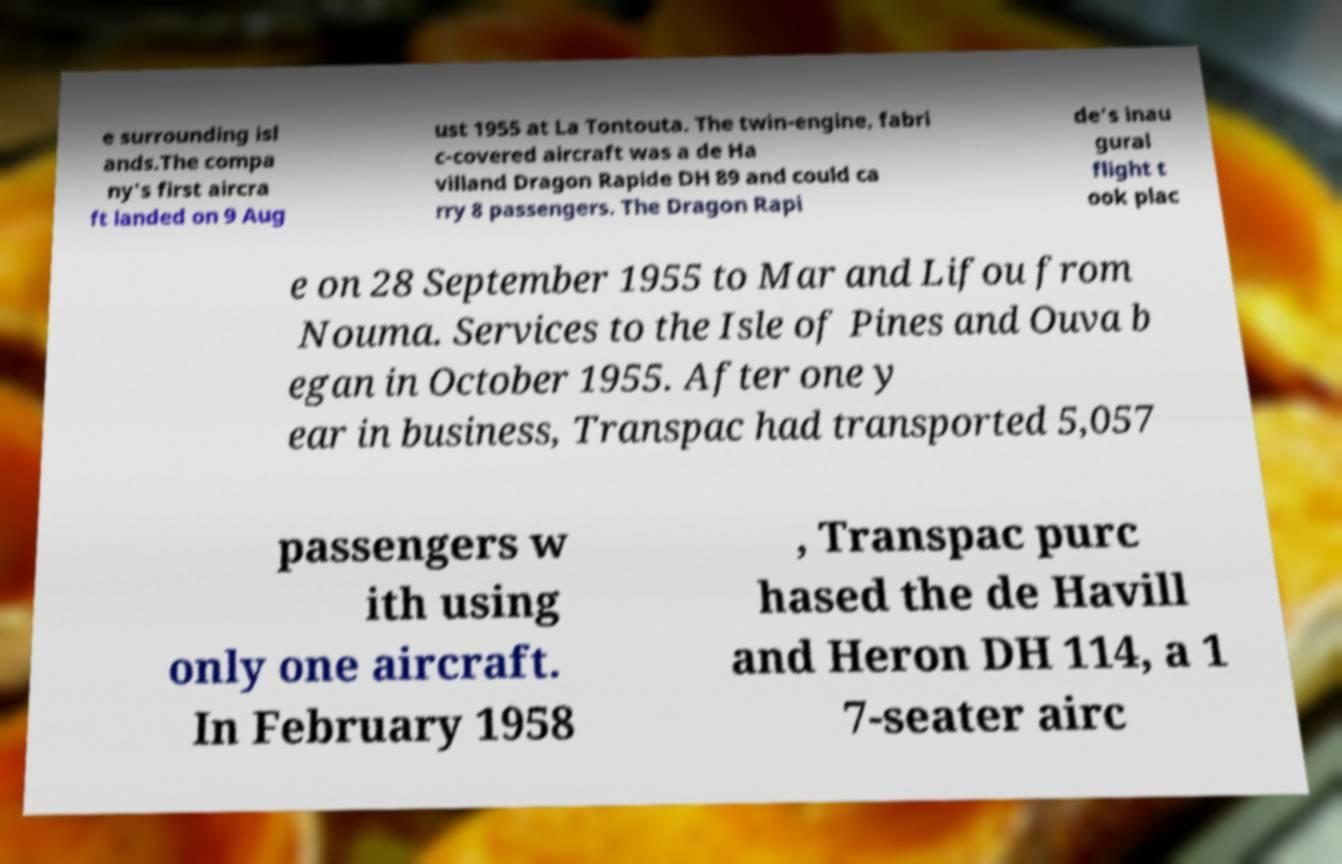Could you extract and type out the text from this image? e surrounding isl ands.The compa ny's first aircra ft landed on 9 Aug ust 1955 at La Tontouta. The twin-engine, fabri c-covered aircraft was a de Ha villand Dragon Rapide DH 89 and could ca rry 8 passengers. The Dragon Rapi de's inau gural flight t ook plac e on 28 September 1955 to Mar and Lifou from Nouma. Services to the Isle of Pines and Ouva b egan in October 1955. After one y ear in business, Transpac had transported 5,057 passengers w ith using only one aircraft. In February 1958 , Transpac purc hased the de Havill and Heron DH 114, a 1 7-seater airc 